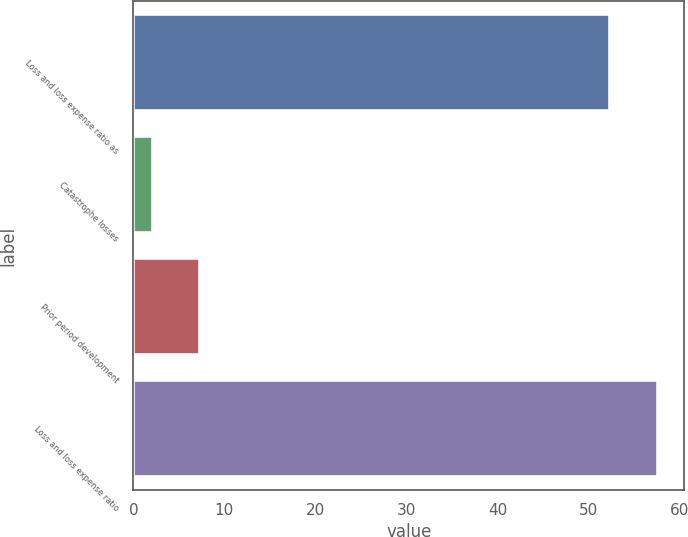Convert chart. <chart><loc_0><loc_0><loc_500><loc_500><bar_chart><fcel>Loss and loss expense ratio as<fcel>Catastrophe losses<fcel>Prior period development<fcel>Loss and loss expense ratio<nl><fcel>52.4<fcel>2.1<fcel>7.33<fcel>57.63<nl></chart> 